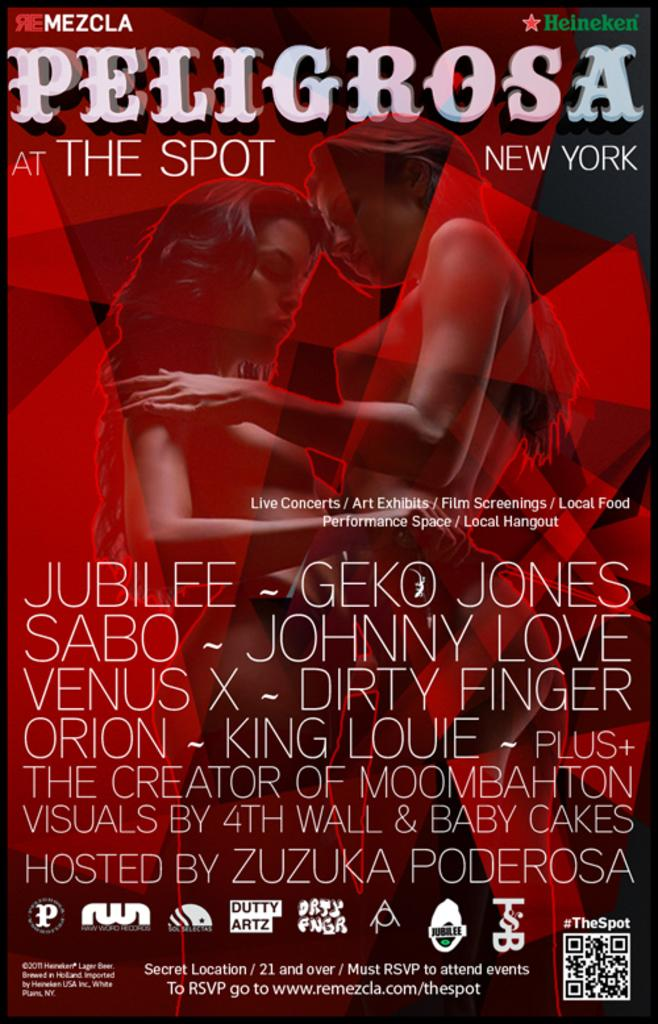<image>
Give a short and clear explanation of the subsequent image. The flyer for the show Peligrosa is sponsored by Heineken beer. 